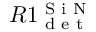Convert formula to latex. <formula><loc_0><loc_0><loc_500><loc_500>R 1 _ { d e t } ^ { S i N }</formula> 